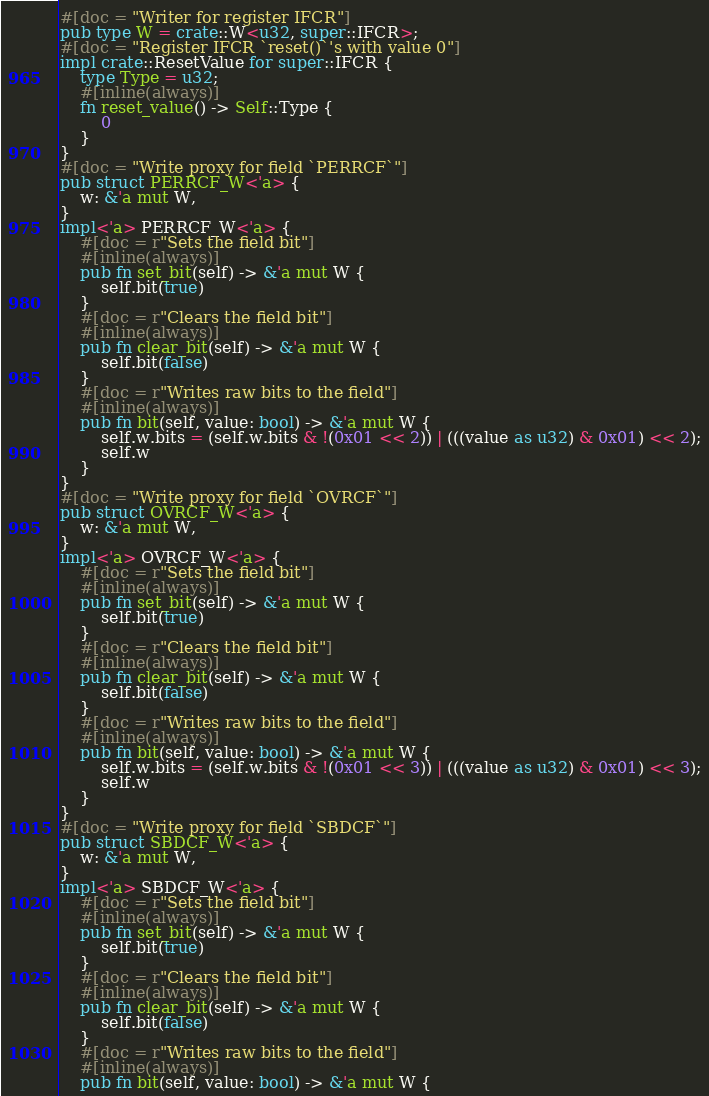Convert code to text. <code><loc_0><loc_0><loc_500><loc_500><_Rust_>#[doc = "Writer for register IFCR"]
pub type W = crate::W<u32, super::IFCR>;
#[doc = "Register IFCR `reset()`'s with value 0"]
impl crate::ResetValue for super::IFCR {
    type Type = u32;
    #[inline(always)]
    fn reset_value() -> Self::Type {
        0
    }
}
#[doc = "Write proxy for field `PERRCF`"]
pub struct PERRCF_W<'a> {
    w: &'a mut W,
}
impl<'a> PERRCF_W<'a> {
    #[doc = r"Sets the field bit"]
    #[inline(always)]
    pub fn set_bit(self) -> &'a mut W {
        self.bit(true)
    }
    #[doc = r"Clears the field bit"]
    #[inline(always)]
    pub fn clear_bit(self) -> &'a mut W {
        self.bit(false)
    }
    #[doc = r"Writes raw bits to the field"]
    #[inline(always)]
    pub fn bit(self, value: bool) -> &'a mut W {
        self.w.bits = (self.w.bits & !(0x01 << 2)) | (((value as u32) & 0x01) << 2);
        self.w
    }
}
#[doc = "Write proxy for field `OVRCF`"]
pub struct OVRCF_W<'a> {
    w: &'a mut W,
}
impl<'a> OVRCF_W<'a> {
    #[doc = r"Sets the field bit"]
    #[inline(always)]
    pub fn set_bit(self) -> &'a mut W {
        self.bit(true)
    }
    #[doc = r"Clears the field bit"]
    #[inline(always)]
    pub fn clear_bit(self) -> &'a mut W {
        self.bit(false)
    }
    #[doc = r"Writes raw bits to the field"]
    #[inline(always)]
    pub fn bit(self, value: bool) -> &'a mut W {
        self.w.bits = (self.w.bits & !(0x01 << 3)) | (((value as u32) & 0x01) << 3);
        self.w
    }
}
#[doc = "Write proxy for field `SBDCF`"]
pub struct SBDCF_W<'a> {
    w: &'a mut W,
}
impl<'a> SBDCF_W<'a> {
    #[doc = r"Sets the field bit"]
    #[inline(always)]
    pub fn set_bit(self) -> &'a mut W {
        self.bit(true)
    }
    #[doc = r"Clears the field bit"]
    #[inline(always)]
    pub fn clear_bit(self) -> &'a mut W {
        self.bit(false)
    }
    #[doc = r"Writes raw bits to the field"]
    #[inline(always)]
    pub fn bit(self, value: bool) -> &'a mut W {</code> 